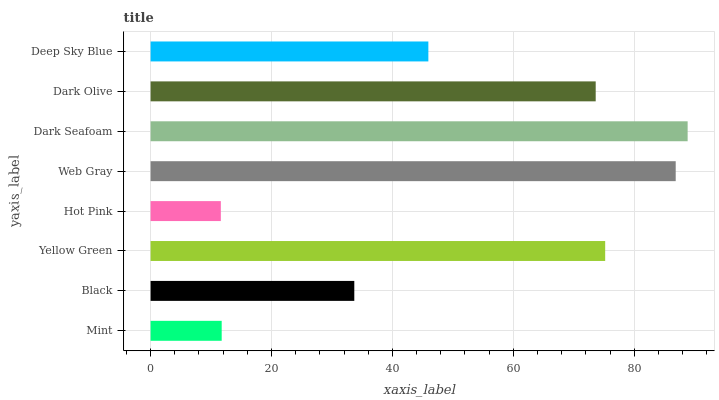Is Hot Pink the minimum?
Answer yes or no. Yes. Is Dark Seafoam the maximum?
Answer yes or no. Yes. Is Black the minimum?
Answer yes or no. No. Is Black the maximum?
Answer yes or no. No. Is Black greater than Mint?
Answer yes or no. Yes. Is Mint less than Black?
Answer yes or no. Yes. Is Mint greater than Black?
Answer yes or no. No. Is Black less than Mint?
Answer yes or no. No. Is Dark Olive the high median?
Answer yes or no. Yes. Is Deep Sky Blue the low median?
Answer yes or no. Yes. Is Mint the high median?
Answer yes or no. No. Is Dark Seafoam the low median?
Answer yes or no. No. 